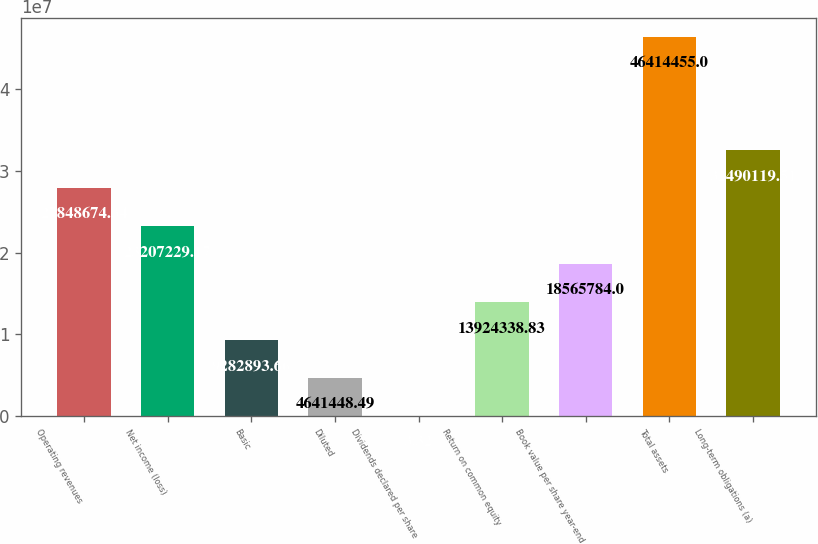Convert chart. <chart><loc_0><loc_0><loc_500><loc_500><bar_chart><fcel>Operating revenues<fcel>Net income (loss)<fcel>Basic<fcel>Diluted<fcel>Dividends declared per share<fcel>Return on common equity<fcel>Book value per share year-end<fcel>Total assets<fcel>Long-term obligations (a)<nl><fcel>2.78487e+07<fcel>2.32072e+07<fcel>9.28289e+06<fcel>4.64145e+06<fcel>3.32<fcel>1.39243e+07<fcel>1.85658e+07<fcel>4.64145e+07<fcel>3.24901e+07<nl></chart> 